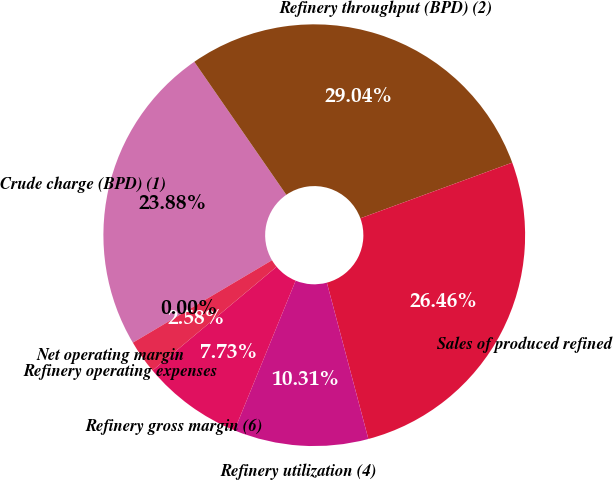<chart> <loc_0><loc_0><loc_500><loc_500><pie_chart><fcel>Crude charge (BPD) (1)<fcel>Refinery throughput (BPD) (2)<fcel>Sales of produced refined<fcel>Refinery utilization (4)<fcel>Refinery gross margin (6)<fcel>Refinery operating expenses<fcel>Net operating margin<nl><fcel>23.88%<fcel>29.04%<fcel>26.46%<fcel>10.31%<fcel>7.73%<fcel>2.58%<fcel>0.0%<nl></chart> 